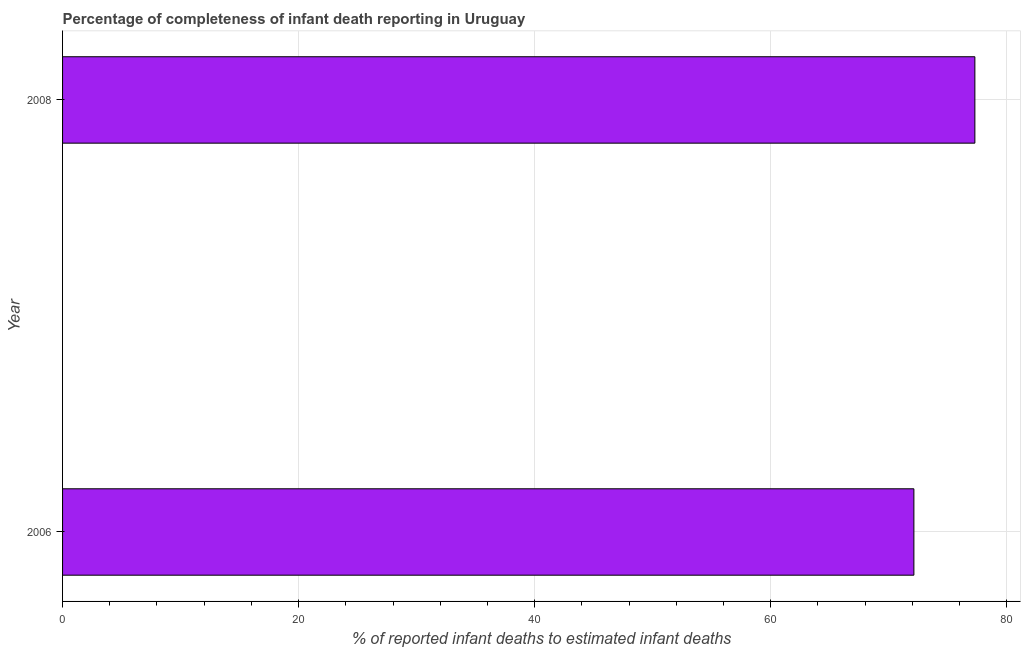Does the graph contain any zero values?
Keep it short and to the point. No. What is the title of the graph?
Provide a short and direct response. Percentage of completeness of infant death reporting in Uruguay. What is the label or title of the X-axis?
Your answer should be very brief. % of reported infant deaths to estimated infant deaths. What is the label or title of the Y-axis?
Ensure brevity in your answer.  Year. What is the completeness of infant death reporting in 2008?
Your answer should be compact. 77.3. Across all years, what is the maximum completeness of infant death reporting?
Offer a very short reply. 77.3. Across all years, what is the minimum completeness of infant death reporting?
Ensure brevity in your answer.  72.13. What is the sum of the completeness of infant death reporting?
Give a very brief answer. 149.43. What is the difference between the completeness of infant death reporting in 2006 and 2008?
Provide a succinct answer. -5.17. What is the average completeness of infant death reporting per year?
Your answer should be very brief. 74.72. What is the median completeness of infant death reporting?
Offer a terse response. 74.72. Do a majority of the years between 2008 and 2006 (inclusive) have completeness of infant death reporting greater than 60 %?
Keep it short and to the point. No. What is the ratio of the completeness of infant death reporting in 2006 to that in 2008?
Keep it short and to the point. 0.93. Is the completeness of infant death reporting in 2006 less than that in 2008?
Your answer should be very brief. Yes. In how many years, is the completeness of infant death reporting greater than the average completeness of infant death reporting taken over all years?
Your answer should be compact. 1. Are all the bars in the graph horizontal?
Offer a very short reply. Yes. What is the difference between two consecutive major ticks on the X-axis?
Give a very brief answer. 20. What is the % of reported infant deaths to estimated infant deaths of 2006?
Your answer should be very brief. 72.13. What is the % of reported infant deaths to estimated infant deaths of 2008?
Offer a terse response. 77.3. What is the difference between the % of reported infant deaths to estimated infant deaths in 2006 and 2008?
Give a very brief answer. -5.17. What is the ratio of the % of reported infant deaths to estimated infant deaths in 2006 to that in 2008?
Offer a very short reply. 0.93. 